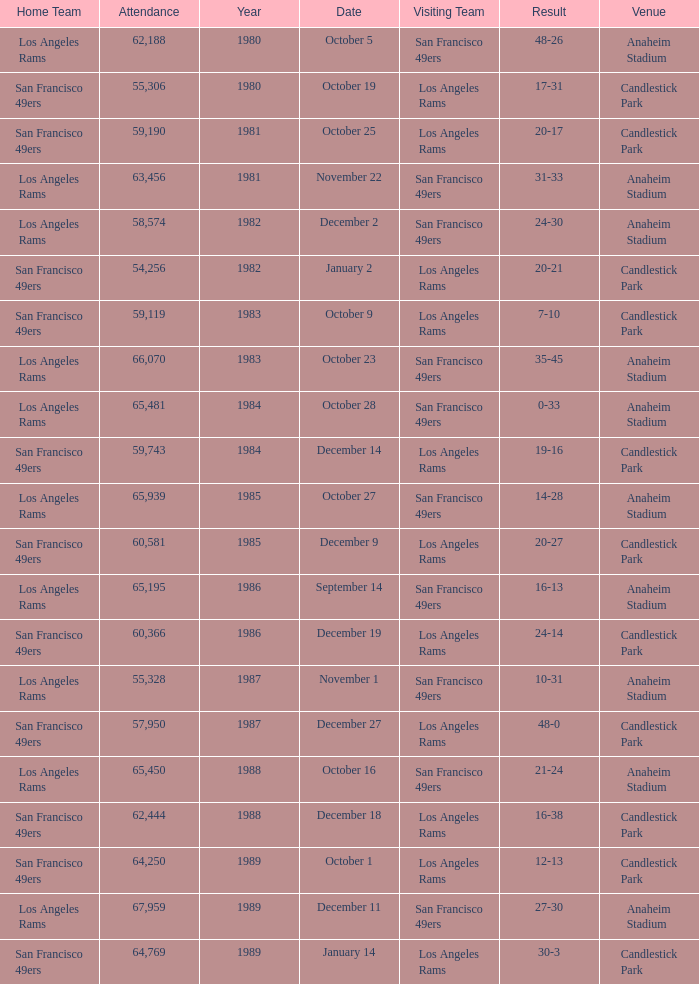What's the total attendance at anaheim stadium after 1983 when the result is 14-28? 1.0. 